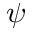<formula> <loc_0><loc_0><loc_500><loc_500>\psi</formula> 